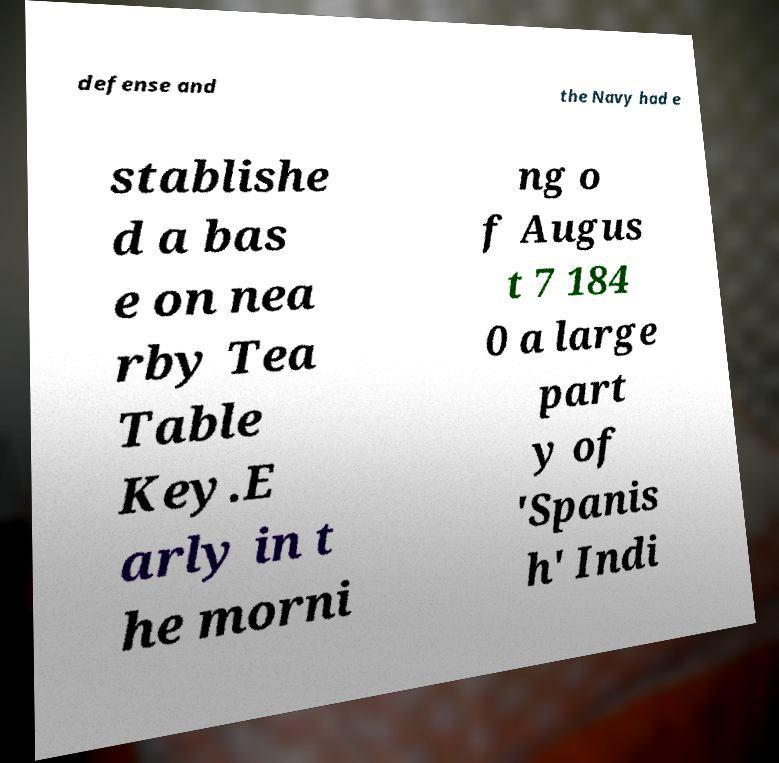Can you read and provide the text displayed in the image?This photo seems to have some interesting text. Can you extract and type it out for me? defense and the Navy had e stablishe d a bas e on nea rby Tea Table Key.E arly in t he morni ng o f Augus t 7 184 0 a large part y of 'Spanis h' Indi 